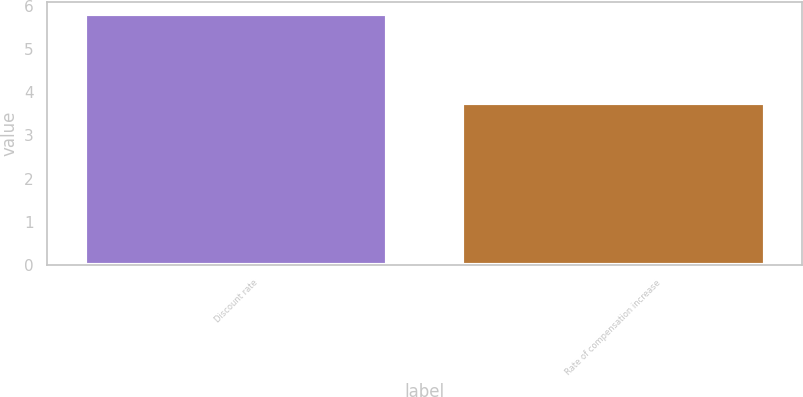<chart> <loc_0><loc_0><loc_500><loc_500><bar_chart><fcel>Discount rate<fcel>Rate of compensation increase<nl><fcel>5.8<fcel>3.75<nl></chart> 